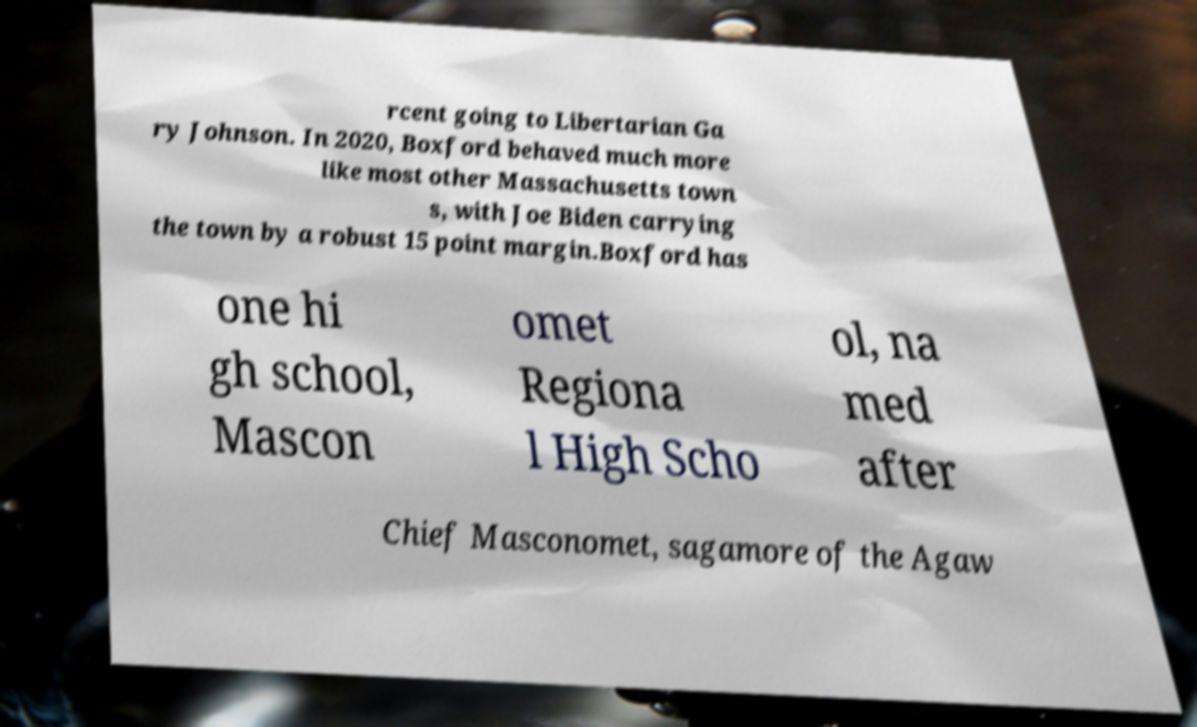Can you accurately transcribe the text from the provided image for me? rcent going to Libertarian Ga ry Johnson. In 2020, Boxford behaved much more like most other Massachusetts town s, with Joe Biden carrying the town by a robust 15 point margin.Boxford has one hi gh school, Mascon omet Regiona l High Scho ol, na med after Chief Masconomet, sagamore of the Agaw 